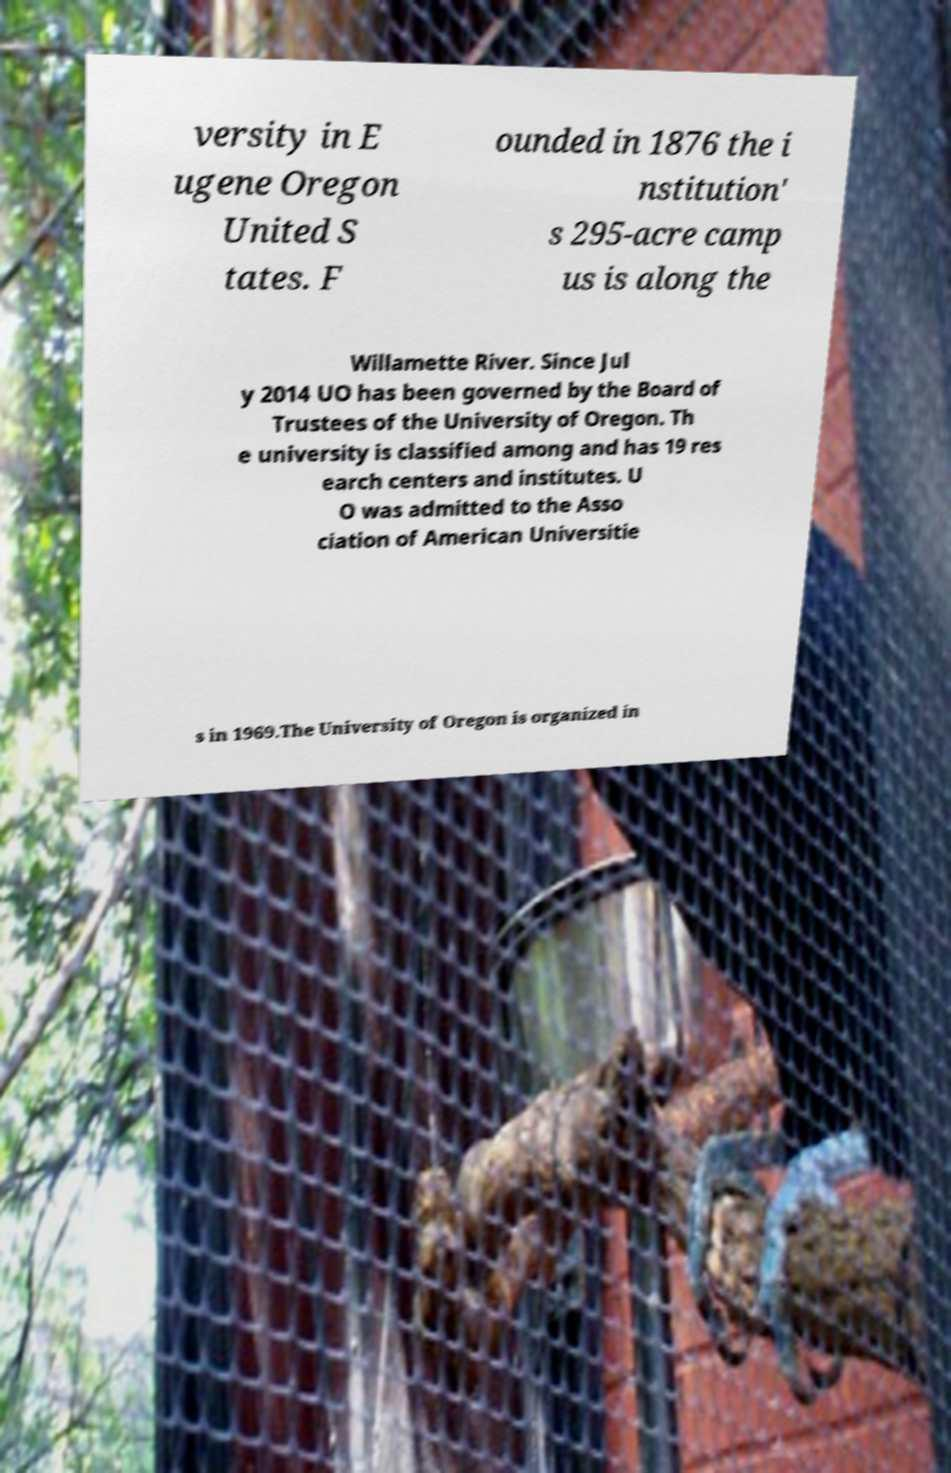Could you assist in decoding the text presented in this image and type it out clearly? versity in E ugene Oregon United S tates. F ounded in 1876 the i nstitution' s 295-acre camp us is along the Willamette River. Since Jul y 2014 UO has been governed by the Board of Trustees of the University of Oregon. Th e university is classified among and has 19 res earch centers and institutes. U O was admitted to the Asso ciation of American Universitie s in 1969.The University of Oregon is organized in 